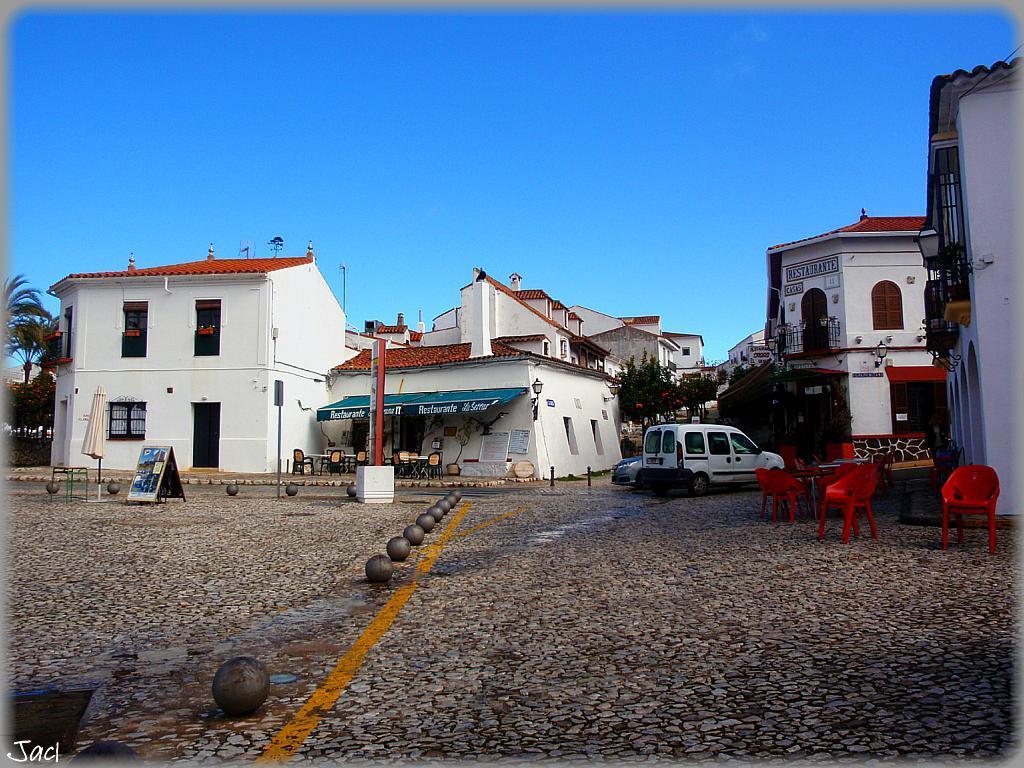Describe this image in one or two sentences. The picture is clicked in an open area. In the background there are buildings, trees, vehicles. In the right there are chairs, tables. Here there are iron balls. Here in the middle there are chairs and table. The sky is clear. On the ground here are cobblestones. 